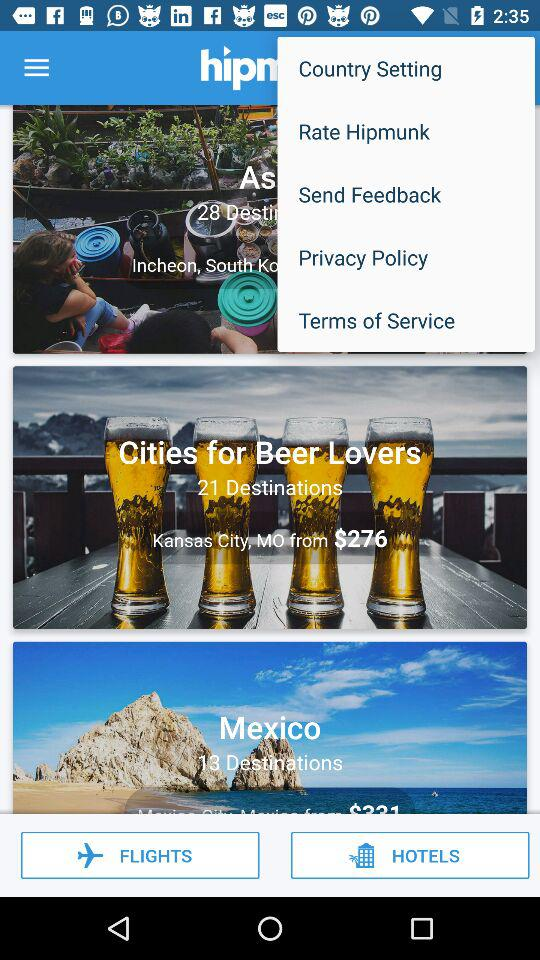What is the status of "Send Feedback"?
When the provided information is insufficient, respond with <no answer>. <no answer> 